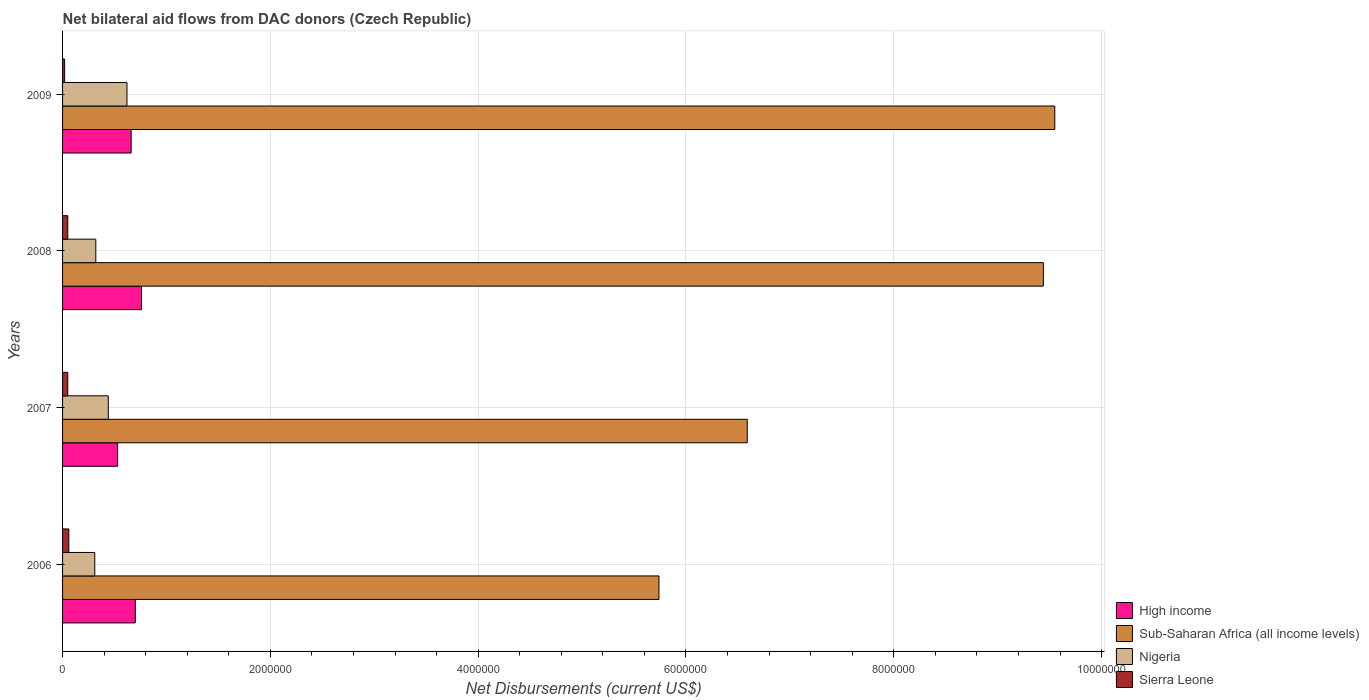How many groups of bars are there?
Keep it short and to the point. 4. Are the number of bars on each tick of the Y-axis equal?
Make the answer very short. Yes. How many bars are there on the 1st tick from the bottom?
Offer a terse response. 4. In how many cases, is the number of bars for a given year not equal to the number of legend labels?
Your answer should be very brief. 0. What is the net bilateral aid flows in Nigeria in 2009?
Your answer should be very brief. 6.20e+05. Across all years, what is the maximum net bilateral aid flows in Sub-Saharan Africa (all income levels)?
Ensure brevity in your answer.  9.55e+06. Across all years, what is the minimum net bilateral aid flows in Sub-Saharan Africa (all income levels)?
Your answer should be compact. 5.74e+06. In which year was the net bilateral aid flows in High income maximum?
Your answer should be compact. 2008. In which year was the net bilateral aid flows in Sub-Saharan Africa (all income levels) minimum?
Ensure brevity in your answer.  2006. What is the total net bilateral aid flows in Nigeria in the graph?
Offer a terse response. 1.69e+06. What is the difference between the net bilateral aid flows in High income in 2008 and that in 2009?
Your answer should be compact. 1.00e+05. What is the difference between the net bilateral aid flows in Sub-Saharan Africa (all income levels) in 2006 and the net bilateral aid flows in Nigeria in 2009?
Offer a terse response. 5.12e+06. What is the average net bilateral aid flows in Nigeria per year?
Ensure brevity in your answer.  4.22e+05. In the year 2008, what is the difference between the net bilateral aid flows in Sub-Saharan Africa (all income levels) and net bilateral aid flows in High income?
Provide a succinct answer. 8.68e+06. What is the ratio of the net bilateral aid flows in Sierra Leone in 2008 to that in 2009?
Offer a terse response. 2.5. Is the net bilateral aid flows in Nigeria in 2008 less than that in 2009?
Your response must be concise. Yes. Is the difference between the net bilateral aid flows in Sub-Saharan Africa (all income levels) in 2007 and 2009 greater than the difference between the net bilateral aid flows in High income in 2007 and 2009?
Your response must be concise. No. What is the difference between the highest and the second highest net bilateral aid flows in High income?
Provide a short and direct response. 6.00e+04. What is the difference between the highest and the lowest net bilateral aid flows in Sub-Saharan Africa (all income levels)?
Offer a very short reply. 3.81e+06. In how many years, is the net bilateral aid flows in High income greater than the average net bilateral aid flows in High income taken over all years?
Offer a terse response. 2. Is the sum of the net bilateral aid flows in Nigeria in 2006 and 2009 greater than the maximum net bilateral aid flows in High income across all years?
Provide a succinct answer. Yes. Is it the case that in every year, the sum of the net bilateral aid flows in Sub-Saharan Africa (all income levels) and net bilateral aid flows in Nigeria is greater than the sum of net bilateral aid flows in High income and net bilateral aid flows in Sierra Leone?
Your answer should be compact. Yes. What does the 3rd bar from the top in 2007 represents?
Your answer should be very brief. Sub-Saharan Africa (all income levels). What does the 4th bar from the bottom in 2006 represents?
Your answer should be very brief. Sierra Leone. What is the difference between two consecutive major ticks on the X-axis?
Your answer should be very brief. 2.00e+06. Where does the legend appear in the graph?
Ensure brevity in your answer.  Bottom right. What is the title of the graph?
Your response must be concise. Net bilateral aid flows from DAC donors (Czech Republic). Does "Sri Lanka" appear as one of the legend labels in the graph?
Keep it short and to the point. No. What is the label or title of the X-axis?
Make the answer very short. Net Disbursements (current US$). What is the label or title of the Y-axis?
Your answer should be very brief. Years. What is the Net Disbursements (current US$) in Sub-Saharan Africa (all income levels) in 2006?
Offer a terse response. 5.74e+06. What is the Net Disbursements (current US$) of Nigeria in 2006?
Ensure brevity in your answer.  3.10e+05. What is the Net Disbursements (current US$) in Sierra Leone in 2006?
Provide a short and direct response. 6.00e+04. What is the Net Disbursements (current US$) in High income in 2007?
Your answer should be very brief. 5.30e+05. What is the Net Disbursements (current US$) in Sub-Saharan Africa (all income levels) in 2007?
Offer a very short reply. 6.59e+06. What is the Net Disbursements (current US$) of Nigeria in 2007?
Provide a short and direct response. 4.40e+05. What is the Net Disbursements (current US$) in Sierra Leone in 2007?
Offer a very short reply. 5.00e+04. What is the Net Disbursements (current US$) in High income in 2008?
Offer a very short reply. 7.60e+05. What is the Net Disbursements (current US$) of Sub-Saharan Africa (all income levels) in 2008?
Provide a short and direct response. 9.44e+06. What is the Net Disbursements (current US$) of Nigeria in 2008?
Your answer should be compact. 3.20e+05. What is the Net Disbursements (current US$) in Sub-Saharan Africa (all income levels) in 2009?
Keep it short and to the point. 9.55e+06. What is the Net Disbursements (current US$) of Nigeria in 2009?
Provide a succinct answer. 6.20e+05. What is the Net Disbursements (current US$) in Sierra Leone in 2009?
Your response must be concise. 2.00e+04. Across all years, what is the maximum Net Disbursements (current US$) of High income?
Ensure brevity in your answer.  7.60e+05. Across all years, what is the maximum Net Disbursements (current US$) of Sub-Saharan Africa (all income levels)?
Keep it short and to the point. 9.55e+06. Across all years, what is the maximum Net Disbursements (current US$) in Nigeria?
Your answer should be very brief. 6.20e+05. Across all years, what is the minimum Net Disbursements (current US$) in High income?
Give a very brief answer. 5.30e+05. Across all years, what is the minimum Net Disbursements (current US$) of Sub-Saharan Africa (all income levels)?
Make the answer very short. 5.74e+06. Across all years, what is the minimum Net Disbursements (current US$) of Nigeria?
Keep it short and to the point. 3.10e+05. What is the total Net Disbursements (current US$) in High income in the graph?
Offer a very short reply. 2.65e+06. What is the total Net Disbursements (current US$) in Sub-Saharan Africa (all income levels) in the graph?
Keep it short and to the point. 3.13e+07. What is the total Net Disbursements (current US$) of Nigeria in the graph?
Provide a succinct answer. 1.69e+06. What is the difference between the Net Disbursements (current US$) in Sub-Saharan Africa (all income levels) in 2006 and that in 2007?
Your answer should be compact. -8.50e+05. What is the difference between the Net Disbursements (current US$) in Nigeria in 2006 and that in 2007?
Your response must be concise. -1.30e+05. What is the difference between the Net Disbursements (current US$) in Sierra Leone in 2006 and that in 2007?
Give a very brief answer. 10000. What is the difference between the Net Disbursements (current US$) in High income in 2006 and that in 2008?
Give a very brief answer. -6.00e+04. What is the difference between the Net Disbursements (current US$) of Sub-Saharan Africa (all income levels) in 2006 and that in 2008?
Make the answer very short. -3.70e+06. What is the difference between the Net Disbursements (current US$) of Nigeria in 2006 and that in 2008?
Your answer should be very brief. -10000. What is the difference between the Net Disbursements (current US$) in Sierra Leone in 2006 and that in 2008?
Provide a short and direct response. 10000. What is the difference between the Net Disbursements (current US$) of Sub-Saharan Africa (all income levels) in 2006 and that in 2009?
Offer a terse response. -3.81e+06. What is the difference between the Net Disbursements (current US$) of Nigeria in 2006 and that in 2009?
Make the answer very short. -3.10e+05. What is the difference between the Net Disbursements (current US$) in Sierra Leone in 2006 and that in 2009?
Keep it short and to the point. 4.00e+04. What is the difference between the Net Disbursements (current US$) in Sub-Saharan Africa (all income levels) in 2007 and that in 2008?
Ensure brevity in your answer.  -2.85e+06. What is the difference between the Net Disbursements (current US$) in Sub-Saharan Africa (all income levels) in 2007 and that in 2009?
Offer a very short reply. -2.96e+06. What is the difference between the Net Disbursements (current US$) in Sierra Leone in 2007 and that in 2009?
Provide a short and direct response. 3.00e+04. What is the difference between the Net Disbursements (current US$) of Sierra Leone in 2008 and that in 2009?
Ensure brevity in your answer.  3.00e+04. What is the difference between the Net Disbursements (current US$) of High income in 2006 and the Net Disbursements (current US$) of Sub-Saharan Africa (all income levels) in 2007?
Offer a terse response. -5.89e+06. What is the difference between the Net Disbursements (current US$) of High income in 2006 and the Net Disbursements (current US$) of Nigeria in 2007?
Give a very brief answer. 2.60e+05. What is the difference between the Net Disbursements (current US$) in High income in 2006 and the Net Disbursements (current US$) in Sierra Leone in 2007?
Keep it short and to the point. 6.50e+05. What is the difference between the Net Disbursements (current US$) of Sub-Saharan Africa (all income levels) in 2006 and the Net Disbursements (current US$) of Nigeria in 2007?
Your answer should be very brief. 5.30e+06. What is the difference between the Net Disbursements (current US$) in Sub-Saharan Africa (all income levels) in 2006 and the Net Disbursements (current US$) in Sierra Leone in 2007?
Provide a short and direct response. 5.69e+06. What is the difference between the Net Disbursements (current US$) of High income in 2006 and the Net Disbursements (current US$) of Sub-Saharan Africa (all income levels) in 2008?
Your response must be concise. -8.74e+06. What is the difference between the Net Disbursements (current US$) in High income in 2006 and the Net Disbursements (current US$) in Nigeria in 2008?
Give a very brief answer. 3.80e+05. What is the difference between the Net Disbursements (current US$) of High income in 2006 and the Net Disbursements (current US$) of Sierra Leone in 2008?
Make the answer very short. 6.50e+05. What is the difference between the Net Disbursements (current US$) in Sub-Saharan Africa (all income levels) in 2006 and the Net Disbursements (current US$) in Nigeria in 2008?
Ensure brevity in your answer.  5.42e+06. What is the difference between the Net Disbursements (current US$) of Sub-Saharan Africa (all income levels) in 2006 and the Net Disbursements (current US$) of Sierra Leone in 2008?
Ensure brevity in your answer.  5.69e+06. What is the difference between the Net Disbursements (current US$) of Nigeria in 2006 and the Net Disbursements (current US$) of Sierra Leone in 2008?
Offer a very short reply. 2.60e+05. What is the difference between the Net Disbursements (current US$) in High income in 2006 and the Net Disbursements (current US$) in Sub-Saharan Africa (all income levels) in 2009?
Make the answer very short. -8.85e+06. What is the difference between the Net Disbursements (current US$) in High income in 2006 and the Net Disbursements (current US$) in Sierra Leone in 2009?
Provide a short and direct response. 6.80e+05. What is the difference between the Net Disbursements (current US$) of Sub-Saharan Africa (all income levels) in 2006 and the Net Disbursements (current US$) of Nigeria in 2009?
Your response must be concise. 5.12e+06. What is the difference between the Net Disbursements (current US$) in Sub-Saharan Africa (all income levels) in 2006 and the Net Disbursements (current US$) in Sierra Leone in 2009?
Provide a succinct answer. 5.72e+06. What is the difference between the Net Disbursements (current US$) of Nigeria in 2006 and the Net Disbursements (current US$) of Sierra Leone in 2009?
Give a very brief answer. 2.90e+05. What is the difference between the Net Disbursements (current US$) in High income in 2007 and the Net Disbursements (current US$) in Sub-Saharan Africa (all income levels) in 2008?
Keep it short and to the point. -8.91e+06. What is the difference between the Net Disbursements (current US$) of High income in 2007 and the Net Disbursements (current US$) of Sierra Leone in 2008?
Your answer should be compact. 4.80e+05. What is the difference between the Net Disbursements (current US$) of Sub-Saharan Africa (all income levels) in 2007 and the Net Disbursements (current US$) of Nigeria in 2008?
Make the answer very short. 6.27e+06. What is the difference between the Net Disbursements (current US$) in Sub-Saharan Africa (all income levels) in 2007 and the Net Disbursements (current US$) in Sierra Leone in 2008?
Offer a terse response. 6.54e+06. What is the difference between the Net Disbursements (current US$) of Nigeria in 2007 and the Net Disbursements (current US$) of Sierra Leone in 2008?
Your answer should be compact. 3.90e+05. What is the difference between the Net Disbursements (current US$) of High income in 2007 and the Net Disbursements (current US$) of Sub-Saharan Africa (all income levels) in 2009?
Keep it short and to the point. -9.02e+06. What is the difference between the Net Disbursements (current US$) in High income in 2007 and the Net Disbursements (current US$) in Sierra Leone in 2009?
Your answer should be compact. 5.10e+05. What is the difference between the Net Disbursements (current US$) in Sub-Saharan Africa (all income levels) in 2007 and the Net Disbursements (current US$) in Nigeria in 2009?
Provide a short and direct response. 5.97e+06. What is the difference between the Net Disbursements (current US$) in Sub-Saharan Africa (all income levels) in 2007 and the Net Disbursements (current US$) in Sierra Leone in 2009?
Provide a succinct answer. 6.57e+06. What is the difference between the Net Disbursements (current US$) in Nigeria in 2007 and the Net Disbursements (current US$) in Sierra Leone in 2009?
Offer a terse response. 4.20e+05. What is the difference between the Net Disbursements (current US$) of High income in 2008 and the Net Disbursements (current US$) of Sub-Saharan Africa (all income levels) in 2009?
Ensure brevity in your answer.  -8.79e+06. What is the difference between the Net Disbursements (current US$) of High income in 2008 and the Net Disbursements (current US$) of Sierra Leone in 2009?
Provide a succinct answer. 7.40e+05. What is the difference between the Net Disbursements (current US$) of Sub-Saharan Africa (all income levels) in 2008 and the Net Disbursements (current US$) of Nigeria in 2009?
Your answer should be compact. 8.82e+06. What is the difference between the Net Disbursements (current US$) in Sub-Saharan Africa (all income levels) in 2008 and the Net Disbursements (current US$) in Sierra Leone in 2009?
Give a very brief answer. 9.42e+06. What is the difference between the Net Disbursements (current US$) of Nigeria in 2008 and the Net Disbursements (current US$) of Sierra Leone in 2009?
Provide a short and direct response. 3.00e+05. What is the average Net Disbursements (current US$) of High income per year?
Ensure brevity in your answer.  6.62e+05. What is the average Net Disbursements (current US$) in Sub-Saharan Africa (all income levels) per year?
Provide a succinct answer. 7.83e+06. What is the average Net Disbursements (current US$) of Nigeria per year?
Ensure brevity in your answer.  4.22e+05. What is the average Net Disbursements (current US$) of Sierra Leone per year?
Ensure brevity in your answer.  4.50e+04. In the year 2006, what is the difference between the Net Disbursements (current US$) in High income and Net Disbursements (current US$) in Sub-Saharan Africa (all income levels)?
Keep it short and to the point. -5.04e+06. In the year 2006, what is the difference between the Net Disbursements (current US$) of High income and Net Disbursements (current US$) of Sierra Leone?
Your answer should be very brief. 6.40e+05. In the year 2006, what is the difference between the Net Disbursements (current US$) in Sub-Saharan Africa (all income levels) and Net Disbursements (current US$) in Nigeria?
Make the answer very short. 5.43e+06. In the year 2006, what is the difference between the Net Disbursements (current US$) of Sub-Saharan Africa (all income levels) and Net Disbursements (current US$) of Sierra Leone?
Your response must be concise. 5.68e+06. In the year 2007, what is the difference between the Net Disbursements (current US$) of High income and Net Disbursements (current US$) of Sub-Saharan Africa (all income levels)?
Give a very brief answer. -6.06e+06. In the year 2007, what is the difference between the Net Disbursements (current US$) of High income and Net Disbursements (current US$) of Sierra Leone?
Your response must be concise. 4.80e+05. In the year 2007, what is the difference between the Net Disbursements (current US$) of Sub-Saharan Africa (all income levels) and Net Disbursements (current US$) of Nigeria?
Provide a short and direct response. 6.15e+06. In the year 2007, what is the difference between the Net Disbursements (current US$) of Sub-Saharan Africa (all income levels) and Net Disbursements (current US$) of Sierra Leone?
Offer a terse response. 6.54e+06. In the year 2008, what is the difference between the Net Disbursements (current US$) in High income and Net Disbursements (current US$) in Sub-Saharan Africa (all income levels)?
Offer a terse response. -8.68e+06. In the year 2008, what is the difference between the Net Disbursements (current US$) in High income and Net Disbursements (current US$) in Nigeria?
Make the answer very short. 4.40e+05. In the year 2008, what is the difference between the Net Disbursements (current US$) in High income and Net Disbursements (current US$) in Sierra Leone?
Keep it short and to the point. 7.10e+05. In the year 2008, what is the difference between the Net Disbursements (current US$) of Sub-Saharan Africa (all income levels) and Net Disbursements (current US$) of Nigeria?
Keep it short and to the point. 9.12e+06. In the year 2008, what is the difference between the Net Disbursements (current US$) in Sub-Saharan Africa (all income levels) and Net Disbursements (current US$) in Sierra Leone?
Keep it short and to the point. 9.39e+06. In the year 2009, what is the difference between the Net Disbursements (current US$) of High income and Net Disbursements (current US$) of Sub-Saharan Africa (all income levels)?
Provide a short and direct response. -8.89e+06. In the year 2009, what is the difference between the Net Disbursements (current US$) in High income and Net Disbursements (current US$) in Sierra Leone?
Provide a short and direct response. 6.40e+05. In the year 2009, what is the difference between the Net Disbursements (current US$) in Sub-Saharan Africa (all income levels) and Net Disbursements (current US$) in Nigeria?
Make the answer very short. 8.93e+06. In the year 2009, what is the difference between the Net Disbursements (current US$) in Sub-Saharan Africa (all income levels) and Net Disbursements (current US$) in Sierra Leone?
Your answer should be very brief. 9.53e+06. In the year 2009, what is the difference between the Net Disbursements (current US$) in Nigeria and Net Disbursements (current US$) in Sierra Leone?
Give a very brief answer. 6.00e+05. What is the ratio of the Net Disbursements (current US$) of High income in 2006 to that in 2007?
Your answer should be compact. 1.32. What is the ratio of the Net Disbursements (current US$) in Sub-Saharan Africa (all income levels) in 2006 to that in 2007?
Offer a very short reply. 0.87. What is the ratio of the Net Disbursements (current US$) in Nigeria in 2006 to that in 2007?
Offer a terse response. 0.7. What is the ratio of the Net Disbursements (current US$) in Sierra Leone in 2006 to that in 2007?
Offer a terse response. 1.2. What is the ratio of the Net Disbursements (current US$) of High income in 2006 to that in 2008?
Your answer should be compact. 0.92. What is the ratio of the Net Disbursements (current US$) in Sub-Saharan Africa (all income levels) in 2006 to that in 2008?
Ensure brevity in your answer.  0.61. What is the ratio of the Net Disbursements (current US$) in Nigeria in 2006 to that in 2008?
Your response must be concise. 0.97. What is the ratio of the Net Disbursements (current US$) of Sierra Leone in 2006 to that in 2008?
Your answer should be compact. 1.2. What is the ratio of the Net Disbursements (current US$) in High income in 2006 to that in 2009?
Provide a succinct answer. 1.06. What is the ratio of the Net Disbursements (current US$) in Sub-Saharan Africa (all income levels) in 2006 to that in 2009?
Ensure brevity in your answer.  0.6. What is the ratio of the Net Disbursements (current US$) of Nigeria in 2006 to that in 2009?
Provide a succinct answer. 0.5. What is the ratio of the Net Disbursements (current US$) in Sierra Leone in 2006 to that in 2009?
Ensure brevity in your answer.  3. What is the ratio of the Net Disbursements (current US$) of High income in 2007 to that in 2008?
Your answer should be compact. 0.7. What is the ratio of the Net Disbursements (current US$) of Sub-Saharan Africa (all income levels) in 2007 to that in 2008?
Provide a succinct answer. 0.7. What is the ratio of the Net Disbursements (current US$) of Nigeria in 2007 to that in 2008?
Provide a short and direct response. 1.38. What is the ratio of the Net Disbursements (current US$) in Sierra Leone in 2007 to that in 2008?
Your answer should be very brief. 1. What is the ratio of the Net Disbursements (current US$) in High income in 2007 to that in 2009?
Offer a terse response. 0.8. What is the ratio of the Net Disbursements (current US$) in Sub-Saharan Africa (all income levels) in 2007 to that in 2009?
Offer a very short reply. 0.69. What is the ratio of the Net Disbursements (current US$) of Nigeria in 2007 to that in 2009?
Your answer should be very brief. 0.71. What is the ratio of the Net Disbursements (current US$) in Sierra Leone in 2007 to that in 2009?
Offer a terse response. 2.5. What is the ratio of the Net Disbursements (current US$) of High income in 2008 to that in 2009?
Your response must be concise. 1.15. What is the ratio of the Net Disbursements (current US$) in Nigeria in 2008 to that in 2009?
Ensure brevity in your answer.  0.52. What is the ratio of the Net Disbursements (current US$) in Sierra Leone in 2008 to that in 2009?
Your answer should be very brief. 2.5. What is the difference between the highest and the second highest Net Disbursements (current US$) in High income?
Make the answer very short. 6.00e+04. What is the difference between the highest and the second highest Net Disbursements (current US$) of Sub-Saharan Africa (all income levels)?
Provide a short and direct response. 1.10e+05. What is the difference between the highest and the second highest Net Disbursements (current US$) in Nigeria?
Your response must be concise. 1.80e+05. What is the difference between the highest and the second highest Net Disbursements (current US$) in Sierra Leone?
Offer a very short reply. 10000. What is the difference between the highest and the lowest Net Disbursements (current US$) in Sub-Saharan Africa (all income levels)?
Offer a very short reply. 3.81e+06. What is the difference between the highest and the lowest Net Disbursements (current US$) in Nigeria?
Offer a terse response. 3.10e+05. 